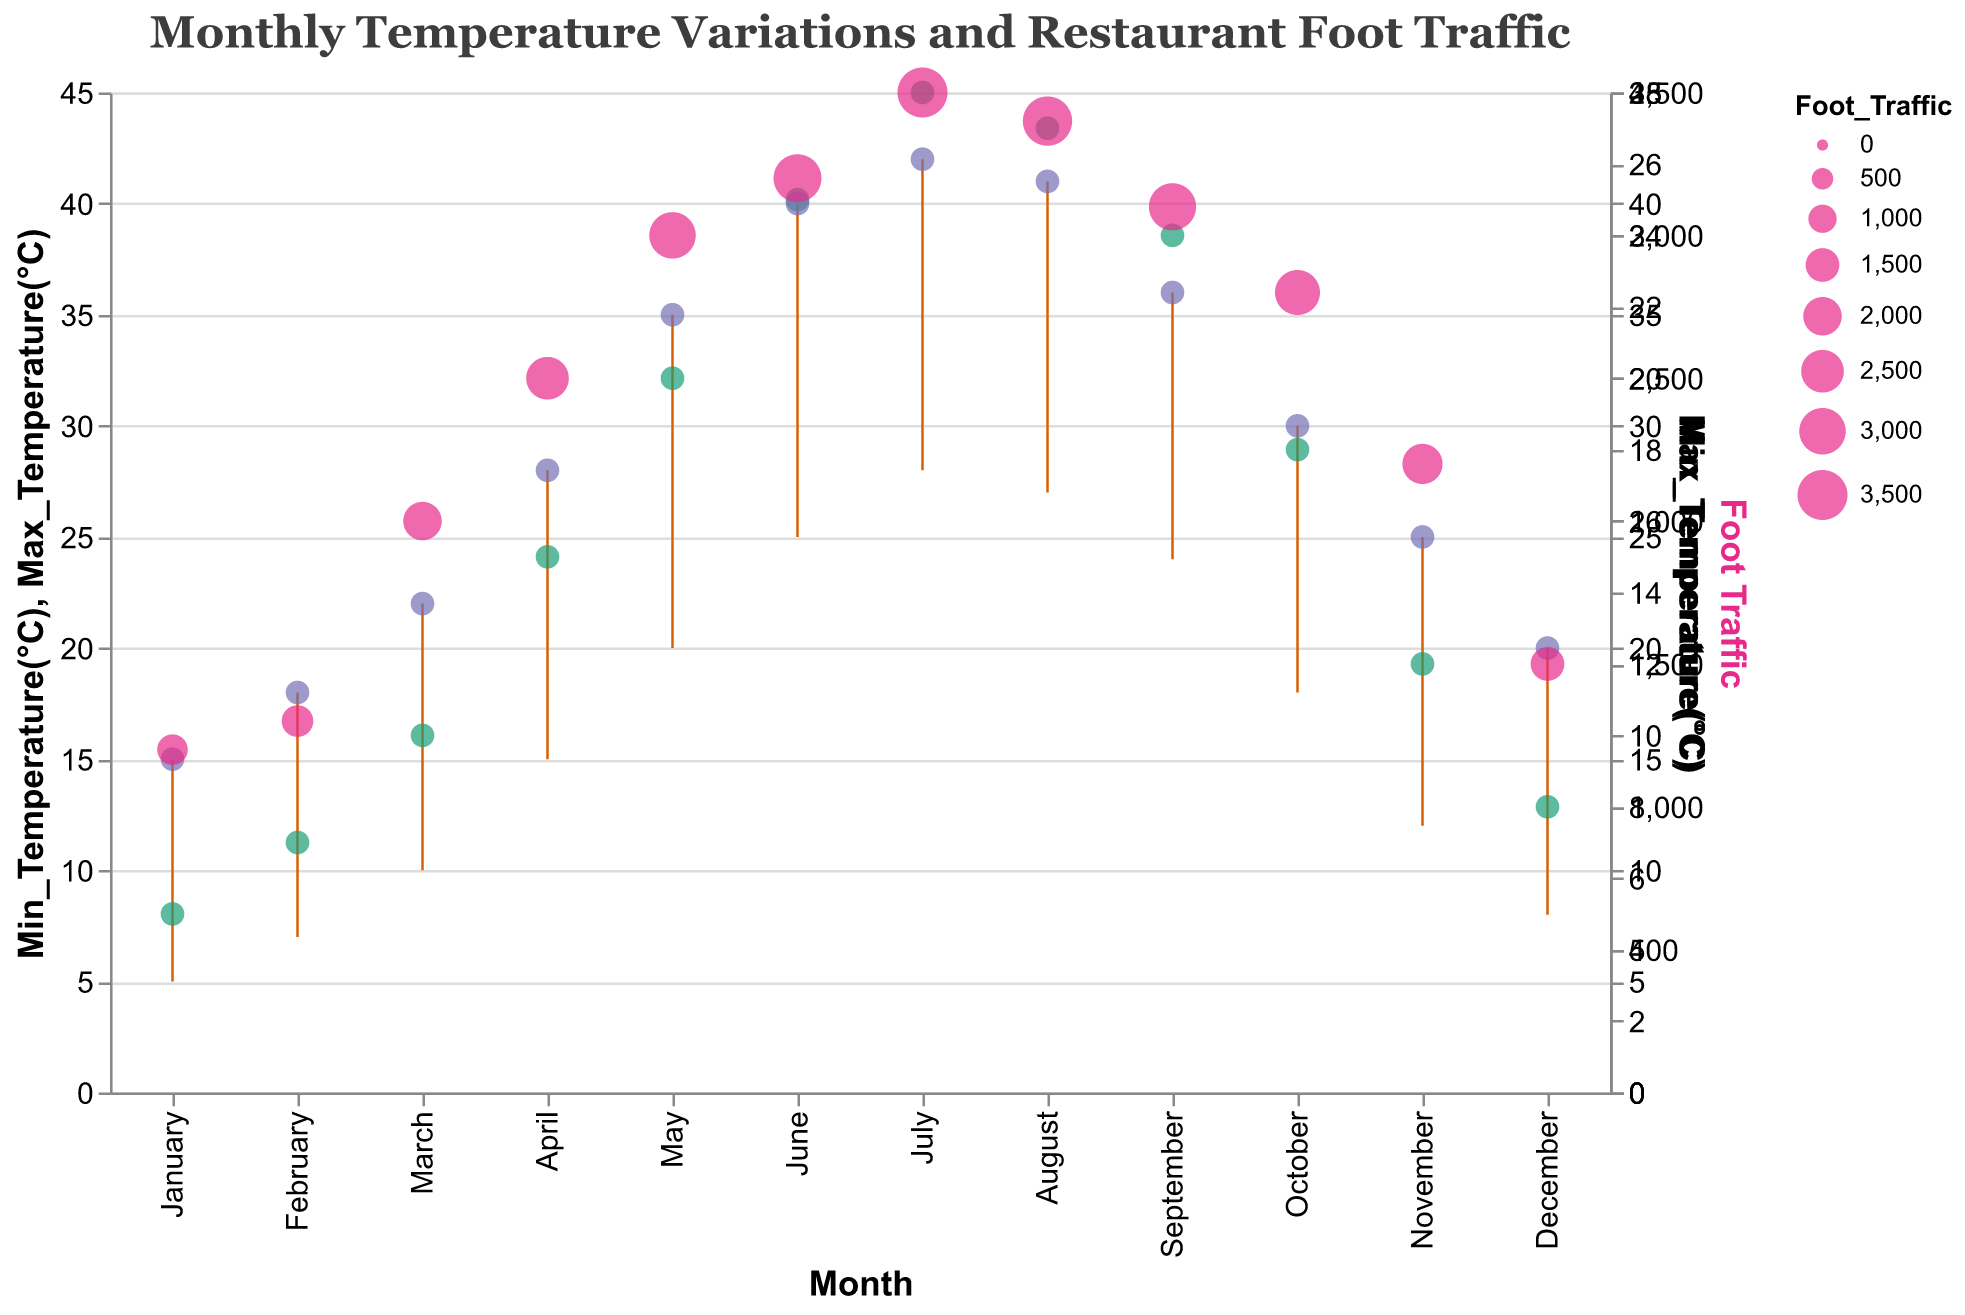What is the maximum temperature in July? The maximum temperature for each month is shown by the higher end of the range represented by the line. In July, the maximum temperature reaches 42°C.
Answer: 42°C How much does foot traffic increase from January to July? Foot traffic in January is 1200, and in July, it is 3500. The increase is calculated by subtracting January's foot traffic from July's: 3500 - 1200 = 2300.
Answer: 2300 Which month has the highest foot traffic? The month with the highest foot traffic can be identified by looking at the largest circle on the graph. July has the largest circle, indicating it has the highest foot traffic at 3500.
Answer: July During which month is the temperature range the widest? To find the widest temperature range, look at the length of the line representing temperature range for each month. July has the widest range from 28°C to 42°C, a difference of 14°C.
Answer: July What is the average minimum temperature in the summer months (June, July, August)? The minimum temperatures for June, July, and August are 25°C, 28°C, and 27°C respectively. The average is calculated as (25 + 28 + 27) / 3 = 26.67°C.
Answer: 26.67°C Which month experiences the smallest change between its minimum and maximum temperatures? The smallest change is found by identifying the shortest line between the minimum and maximum temperatures. January has the smallest range, with a minimum of 5°C and a maximum of 15°C, a difference of 10°C.
Answer: January How does foot traffic correlate with increasing temperatures, based on the graph? By observing the graph, as temperatures increase from January to July, foot traffic also increases, peaking in July. After July, though temperatures remain high, foot traffic decreases slightly. This suggests a positive correlation between temperature and foot traffic up to a point (July).
Answer: Positive correlation up to July Compare the foot traffic in April and September. Which is higher? The size of the circle indicates foot traffic. The circle for April and September can be compared directly: April has a foot traffic of 2500, and September has 3100. Therefore, September has higher foot traffic.
Answer: September Is there a month where the foot traffic is lower despite higher temperatures? Comparing the temperature range and foot traffic, in January the foot traffic is quite low (1200) despite some other months having both lower minimum temperatures and lower foot traffic, like February (1300) and December (1500). However, among months with higher temperatures, December has lower foot traffic despite higher max temperatures.
Answer: December What is the temperature difference between March and November? The temperature difference involves both min and max temperatures. For March, the range is 10°C to 22°C, and for November, it is 12°C to 25°C. Thus, max temperature difference is 25 - 22 = 3°C, and min temperature difference is 12 - 10 = 2°C. Both differences need considering: a range from 2°C to 3°C.
Answer: 2°C to 3°C 